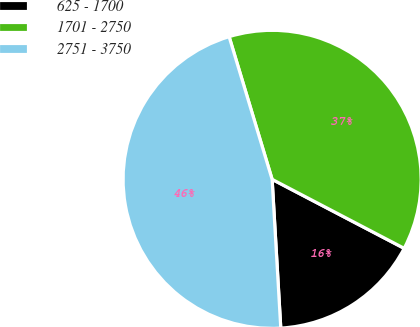Convert chart to OTSL. <chart><loc_0><loc_0><loc_500><loc_500><pie_chart><fcel>625 - 1700<fcel>1701 - 2750<fcel>2751 - 3750<nl><fcel>16.41%<fcel>37.32%<fcel>46.26%<nl></chart> 